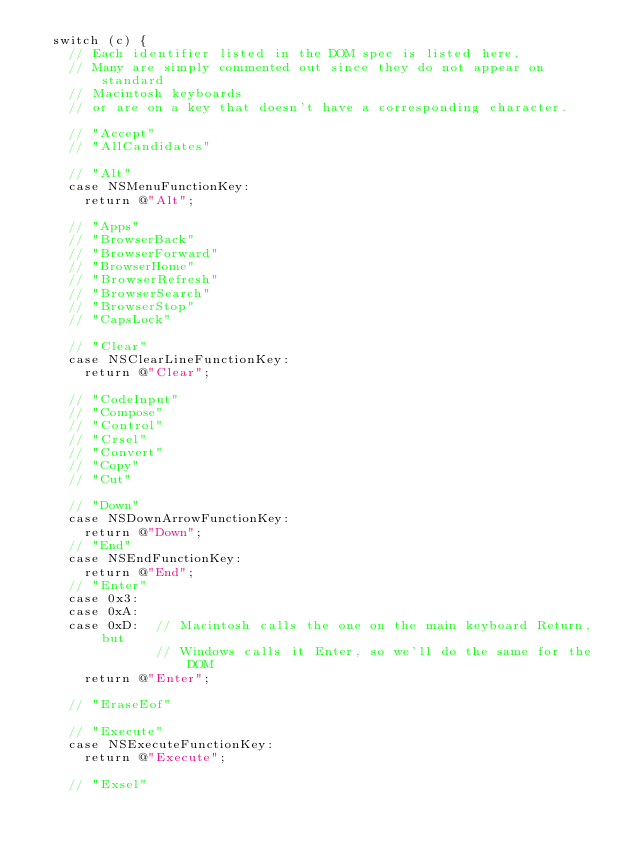Convert code to text. <code><loc_0><loc_0><loc_500><loc_500><_ObjectiveC_>  switch (c) {
    // Each identifier listed in the DOM spec is listed here.
    // Many are simply commented out since they do not appear on standard
    // Macintosh keyboards
    // or are on a key that doesn't have a corresponding character.

    // "Accept"
    // "AllCandidates"

    // "Alt"
    case NSMenuFunctionKey:
      return @"Alt";

    // "Apps"
    // "BrowserBack"
    // "BrowserForward"
    // "BrowserHome"
    // "BrowserRefresh"
    // "BrowserSearch"
    // "BrowserStop"
    // "CapsLock"

    // "Clear"
    case NSClearLineFunctionKey:
      return @"Clear";

    // "CodeInput"
    // "Compose"
    // "Control"
    // "Crsel"
    // "Convert"
    // "Copy"
    // "Cut"

    // "Down"
    case NSDownArrowFunctionKey:
      return @"Down";
    // "End"
    case NSEndFunctionKey:
      return @"End";
    // "Enter"
    case 0x3:
    case 0xA:
    case 0xD:  // Macintosh calls the one on the main keyboard Return, but
               // Windows calls it Enter, so we'll do the same for the DOM
      return @"Enter";

    // "EraseEof"

    // "Execute"
    case NSExecuteFunctionKey:
      return @"Execute";

    // "Exsel"
</code> 